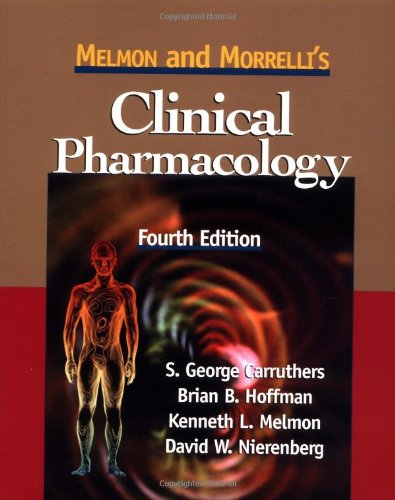Can you tell me more about the main topics covered in this book? This book covers a comprehensive range of topics in clinical pharmacology including drug interactions, therapeutic strategies, and the mechanisms of drug action. It is a valuable resource for healthcare professionals to understand the pharmacokinetic and pharmacodynamic aspects of drugs. 